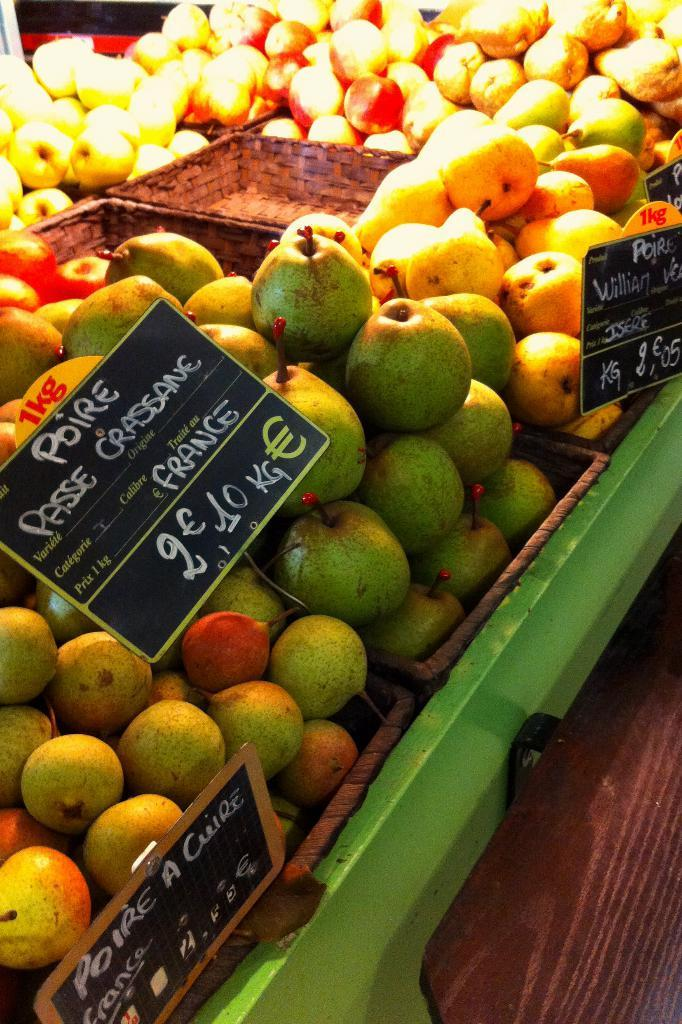What type of food can be seen in the image? There are fruits in the image. How are the fruits arranged or contained in the image? The fruits are in wooden baskets. What color is the spot on the wall in the image? There is no mention of a spot or a wall in the image, so it is not possible to answer that question. 